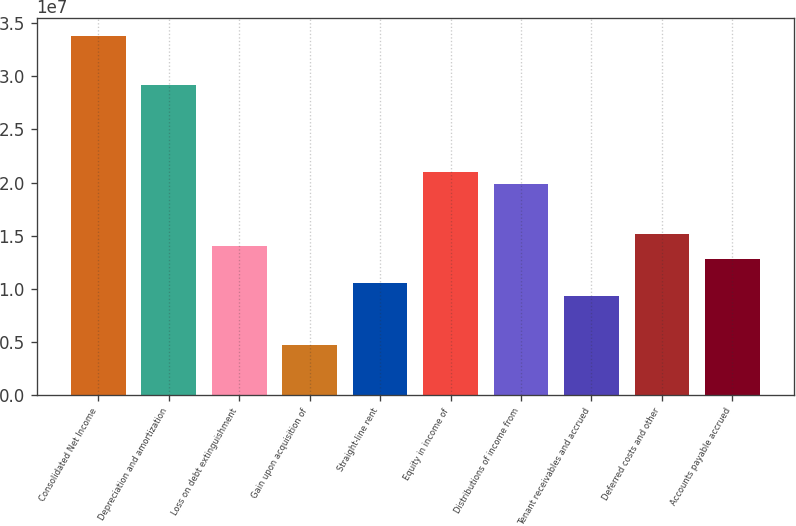Convert chart. <chart><loc_0><loc_0><loc_500><loc_500><bar_chart><fcel>Consolidated Net Income<fcel>Depreciation and amortization<fcel>Loss on debt extinguishment<fcel>Gain upon acquisition of<fcel>Straight-line rent<fcel>Equity in income of<fcel>Distributions of income from<fcel>Tenant receivables and accrued<fcel>Deferred costs and other<fcel>Accounts payable accrued<nl><fcel>3.38367e+07<fcel>2.91696e+07<fcel>1.40016e+07<fcel>4.66741e+06<fcel>1.05013e+07<fcel>2.10022e+07<fcel>1.98354e+07<fcel>9.33449e+06<fcel>1.51683e+07<fcel>1.28348e+07<nl></chart> 